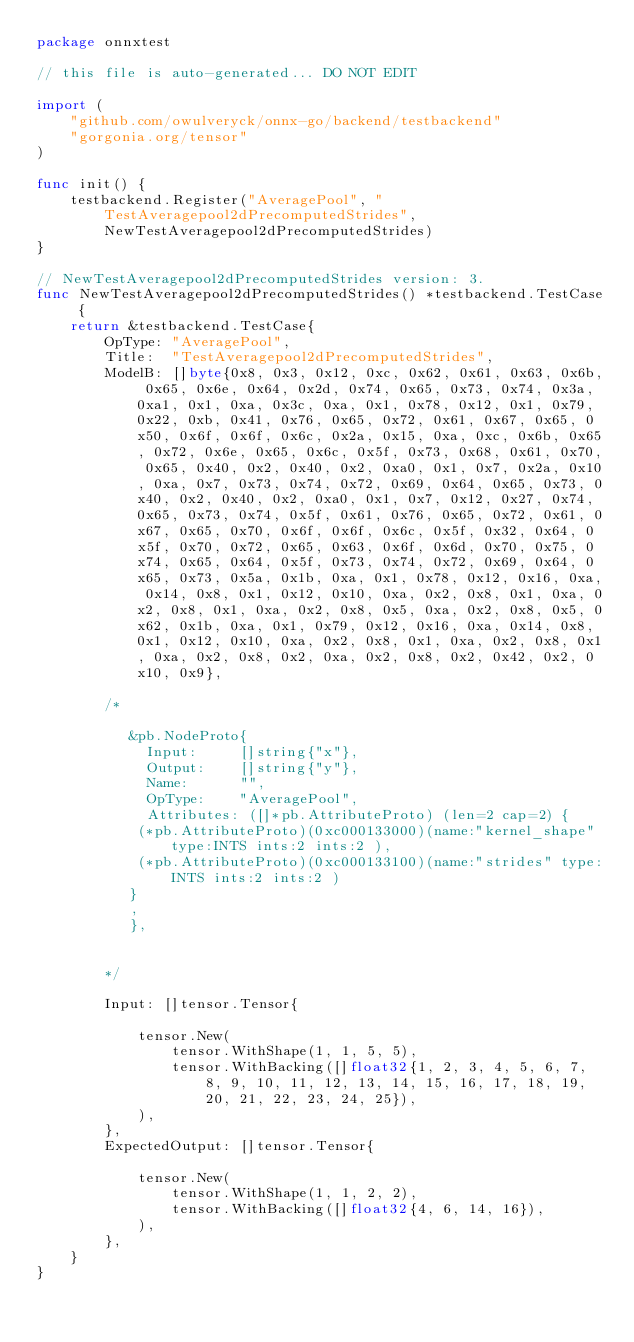<code> <loc_0><loc_0><loc_500><loc_500><_Go_>package onnxtest

// this file is auto-generated... DO NOT EDIT

import (
	"github.com/owulveryck/onnx-go/backend/testbackend"
	"gorgonia.org/tensor"
)

func init() {
	testbackend.Register("AveragePool", "TestAveragepool2dPrecomputedStrides", NewTestAveragepool2dPrecomputedStrides)
}

// NewTestAveragepool2dPrecomputedStrides version: 3.
func NewTestAveragepool2dPrecomputedStrides() *testbackend.TestCase {
	return &testbackend.TestCase{
		OpType: "AveragePool",
		Title:  "TestAveragepool2dPrecomputedStrides",
		ModelB: []byte{0x8, 0x3, 0x12, 0xc, 0x62, 0x61, 0x63, 0x6b, 0x65, 0x6e, 0x64, 0x2d, 0x74, 0x65, 0x73, 0x74, 0x3a, 0xa1, 0x1, 0xa, 0x3c, 0xa, 0x1, 0x78, 0x12, 0x1, 0x79, 0x22, 0xb, 0x41, 0x76, 0x65, 0x72, 0x61, 0x67, 0x65, 0x50, 0x6f, 0x6f, 0x6c, 0x2a, 0x15, 0xa, 0xc, 0x6b, 0x65, 0x72, 0x6e, 0x65, 0x6c, 0x5f, 0x73, 0x68, 0x61, 0x70, 0x65, 0x40, 0x2, 0x40, 0x2, 0xa0, 0x1, 0x7, 0x2a, 0x10, 0xa, 0x7, 0x73, 0x74, 0x72, 0x69, 0x64, 0x65, 0x73, 0x40, 0x2, 0x40, 0x2, 0xa0, 0x1, 0x7, 0x12, 0x27, 0x74, 0x65, 0x73, 0x74, 0x5f, 0x61, 0x76, 0x65, 0x72, 0x61, 0x67, 0x65, 0x70, 0x6f, 0x6f, 0x6c, 0x5f, 0x32, 0x64, 0x5f, 0x70, 0x72, 0x65, 0x63, 0x6f, 0x6d, 0x70, 0x75, 0x74, 0x65, 0x64, 0x5f, 0x73, 0x74, 0x72, 0x69, 0x64, 0x65, 0x73, 0x5a, 0x1b, 0xa, 0x1, 0x78, 0x12, 0x16, 0xa, 0x14, 0x8, 0x1, 0x12, 0x10, 0xa, 0x2, 0x8, 0x1, 0xa, 0x2, 0x8, 0x1, 0xa, 0x2, 0x8, 0x5, 0xa, 0x2, 0x8, 0x5, 0x62, 0x1b, 0xa, 0x1, 0x79, 0x12, 0x16, 0xa, 0x14, 0x8, 0x1, 0x12, 0x10, 0xa, 0x2, 0x8, 0x1, 0xa, 0x2, 0x8, 0x1, 0xa, 0x2, 0x8, 0x2, 0xa, 0x2, 0x8, 0x2, 0x42, 0x2, 0x10, 0x9},

		/*

		   &pb.NodeProto{
		     Input:     []string{"x"},
		     Output:    []string{"y"},
		     Name:      "",
		     OpType:    "AveragePool",
		     Attributes: ([]*pb.AttributeProto) (len=2 cap=2) {
		    (*pb.AttributeProto)(0xc000133000)(name:"kernel_shape" type:INTS ints:2 ints:2 ),
		    (*pb.AttributeProto)(0xc000133100)(name:"strides" type:INTS ints:2 ints:2 )
		   }
		   ,
		   },


		*/

		Input: []tensor.Tensor{

			tensor.New(
				tensor.WithShape(1, 1, 5, 5),
				tensor.WithBacking([]float32{1, 2, 3, 4, 5, 6, 7, 8, 9, 10, 11, 12, 13, 14, 15, 16, 17, 18, 19, 20, 21, 22, 23, 24, 25}),
			),
		},
		ExpectedOutput: []tensor.Tensor{

			tensor.New(
				tensor.WithShape(1, 1, 2, 2),
				tensor.WithBacking([]float32{4, 6, 14, 16}),
			),
		},
	}
}
</code> 